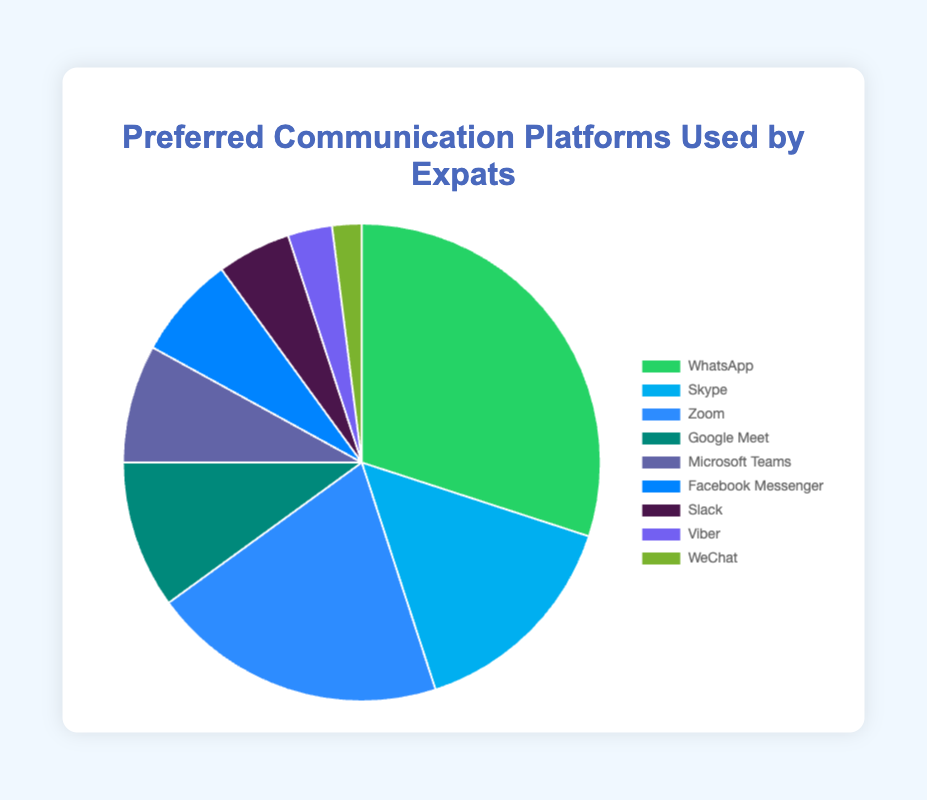Which platform is the most preferred by expats? By looking at the pie chart, we can see that the largest section belongs to WhatsApp.
Answer: WhatsApp Which platforms combined make up more than 50% of the preferred choices? Adding the percentages of WhatsApp (30%), Skype (15%), and Zoom (20%) gives us 30 + 15 + 20 = 65%, which is more than 50%.
Answer: WhatsApp, Skype, and Zoom How does the usage of Facebook Messenger compare to Slack? According to the pie chart, Facebook Messenger's usage (7%) is higher than Slack's usage (5%).
Answer: Facebook Messenger has higher usage than Slack Which platform represents the smallest portion of the pie chart? By examining the smallest slice of the pie chart, we see that WeChat represents the smallest portion at 2%.
Answer: WeChat What is the difference in percentage between the uses of Microsoft Teams and Google Meet? Looking at the chart, Microsoft Teams has 8% and Google Meet has 10%. The difference is 10 - 8 = 2%.
Answer: 2% What percentage of expats use YouTube as their preferred communication platform? YouTube is not included in the list of preferred communication platforms in the chart.
Answer: 0% If you combine the usage percentages of Viber, WeChat, and Slack, what is the total percentage? Summing up Viber (3%), WeChat (2%), and Slack (5%) gives 3 + 2 + 5 = 10%.
Answer: 10% Between Zoom and Google Meet, which platform is more preferred, and by what percentage? Zoom has a 20% share and Google Meet has a 10% share. Zoom is more preferred by 20 - 10 = 10%.
Answer: Zoom, by 10% Is the combined usage of Microsoft Teams and Slack greater than the usage of Skype? The combined usage of Microsoft Teams (8%) and Slack (5%) is 8 + 5 = 13%, which is less than Skype’s 15%.
Answer: No, it is less than Skype’s usage Which platform usage is closest to 25%? By looking at the pie chart, we see that WhatsApp's usage of 30% is closest to 25%.
Answer: WhatsApp 